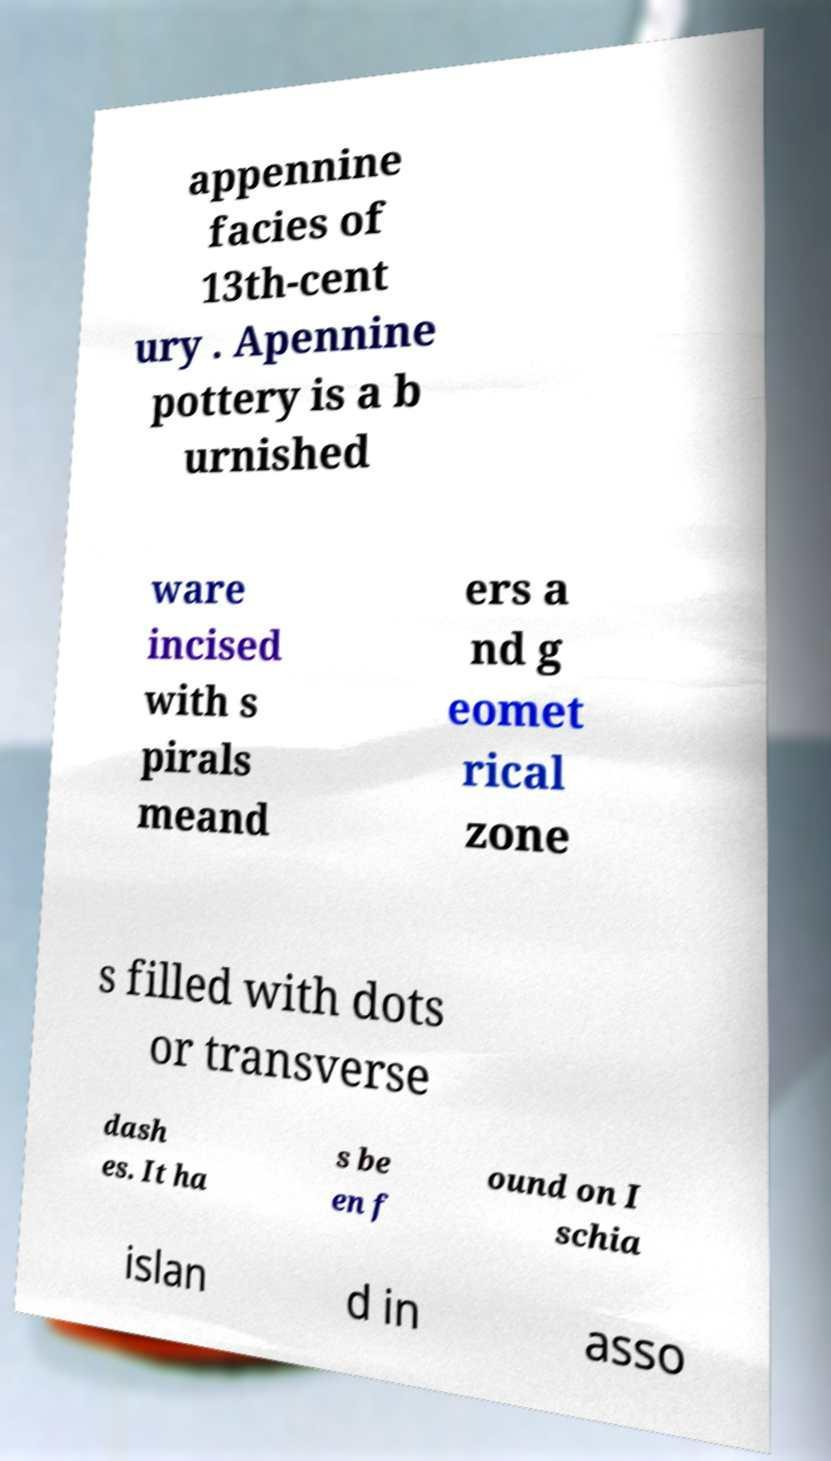For documentation purposes, I need the text within this image transcribed. Could you provide that? appennine facies of 13th-cent ury . Apennine pottery is a b urnished ware incised with s pirals meand ers a nd g eomet rical zone s filled with dots or transverse dash es. It ha s be en f ound on I schia islan d in asso 